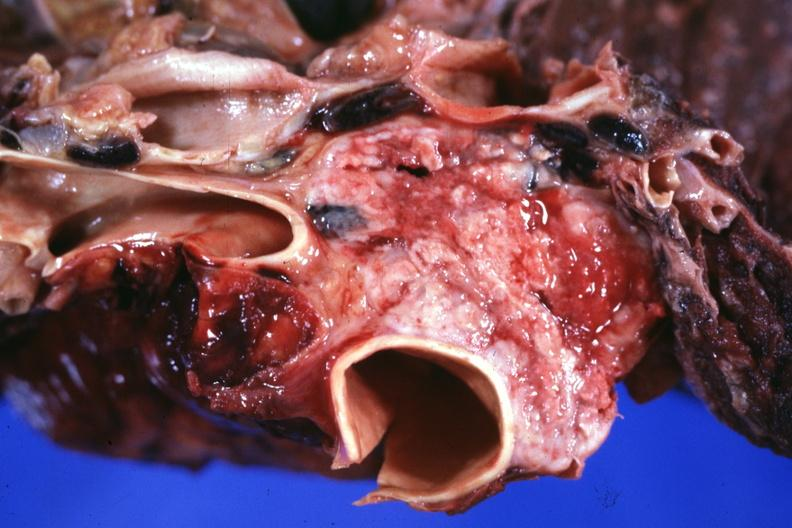where is this part in?
Answer the question using a single word or phrase. Thymus 